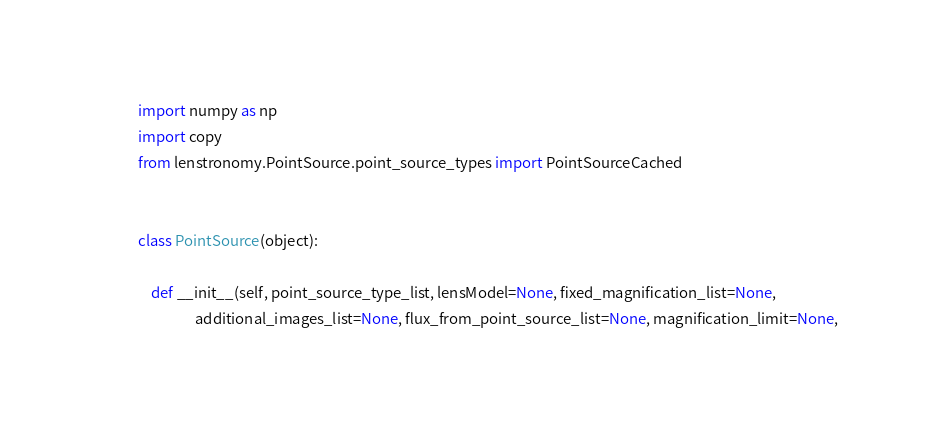<code> <loc_0><loc_0><loc_500><loc_500><_Python_>import numpy as np
import copy
from lenstronomy.PointSource.point_source_types import PointSourceCached


class PointSource(object):

    def __init__(self, point_source_type_list, lensModel=None, fixed_magnification_list=None,
                 additional_images_list=None, flux_from_point_source_list=None, magnification_limit=None,</code> 